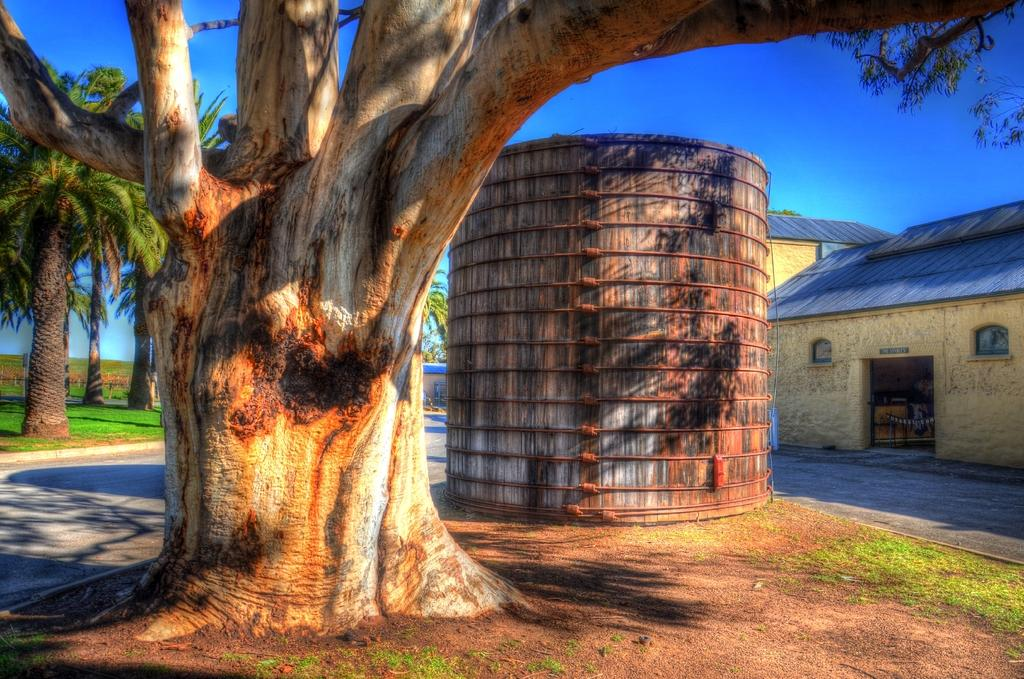What type of plant can be seen in the image? There is a tree in the image. What other object is present in the image? There is an object in the image, but its specific nature is not mentioned in the facts. What can be seen to the right of the image? There are houses to the right of the image. What is visible in the background of the image? Many trees and a blue sky are visible in the background of the image. What time of day is it in the image, and how many tomatoes are on the level? The time of day is not mentioned in the facts, and there are no tomatoes or levels present in the image. 